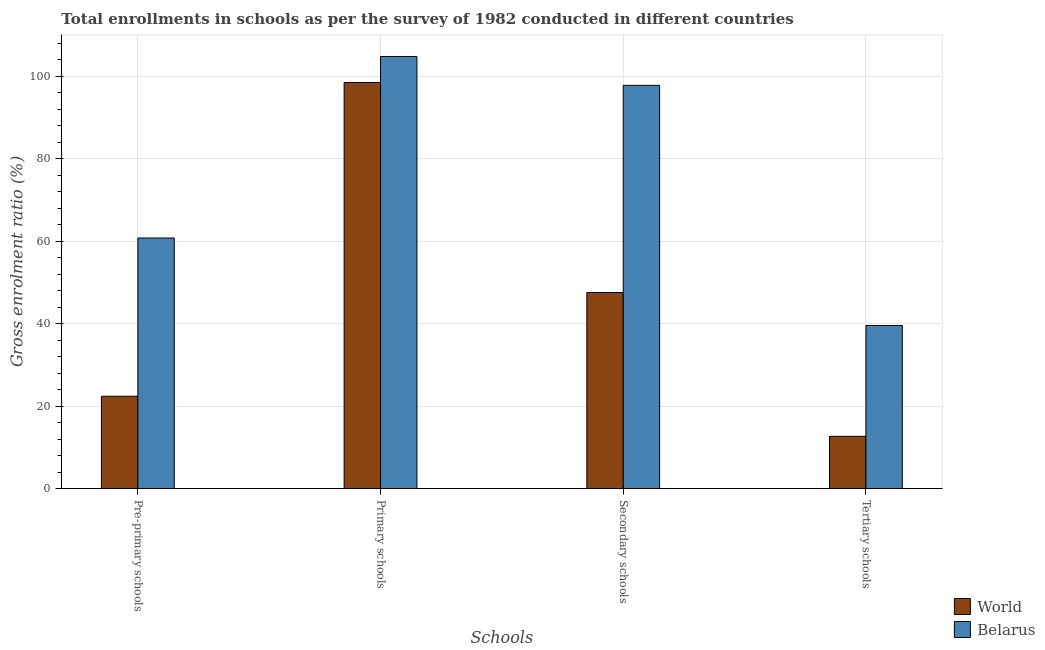How many different coloured bars are there?
Your answer should be very brief. 2. Are the number of bars per tick equal to the number of legend labels?
Your response must be concise. Yes. Are the number of bars on each tick of the X-axis equal?
Offer a very short reply. Yes. How many bars are there on the 4th tick from the left?
Offer a very short reply. 2. How many bars are there on the 1st tick from the right?
Offer a terse response. 2. What is the label of the 2nd group of bars from the left?
Make the answer very short. Primary schools. What is the gross enrolment ratio in pre-primary schools in World?
Your answer should be very brief. 22.41. Across all countries, what is the maximum gross enrolment ratio in pre-primary schools?
Provide a succinct answer. 60.76. Across all countries, what is the minimum gross enrolment ratio in pre-primary schools?
Your answer should be very brief. 22.41. In which country was the gross enrolment ratio in primary schools maximum?
Your answer should be very brief. Belarus. In which country was the gross enrolment ratio in pre-primary schools minimum?
Give a very brief answer. World. What is the total gross enrolment ratio in tertiary schools in the graph?
Provide a short and direct response. 52.24. What is the difference between the gross enrolment ratio in primary schools in Belarus and that in World?
Provide a succinct answer. 6.3. What is the difference between the gross enrolment ratio in tertiary schools in World and the gross enrolment ratio in pre-primary schools in Belarus?
Your response must be concise. -48.07. What is the average gross enrolment ratio in primary schools per country?
Make the answer very short. 101.61. What is the difference between the gross enrolment ratio in secondary schools and gross enrolment ratio in primary schools in World?
Your response must be concise. -50.91. In how many countries, is the gross enrolment ratio in primary schools greater than 68 %?
Give a very brief answer. 2. What is the ratio of the gross enrolment ratio in pre-primary schools in World to that in Belarus?
Make the answer very short. 0.37. What is the difference between the highest and the second highest gross enrolment ratio in tertiary schools?
Keep it short and to the point. 26.87. What is the difference between the highest and the lowest gross enrolment ratio in pre-primary schools?
Provide a short and direct response. 38.35. In how many countries, is the gross enrolment ratio in pre-primary schools greater than the average gross enrolment ratio in pre-primary schools taken over all countries?
Your answer should be compact. 1. What does the 2nd bar from the left in Secondary schools represents?
Keep it short and to the point. Belarus. What does the 1st bar from the right in Primary schools represents?
Ensure brevity in your answer.  Belarus. How many countries are there in the graph?
Offer a very short reply. 2. What is the difference between two consecutive major ticks on the Y-axis?
Your answer should be compact. 20. Are the values on the major ticks of Y-axis written in scientific E-notation?
Keep it short and to the point. No. Does the graph contain grids?
Give a very brief answer. Yes. What is the title of the graph?
Give a very brief answer. Total enrollments in schools as per the survey of 1982 conducted in different countries. What is the label or title of the X-axis?
Offer a terse response. Schools. What is the label or title of the Y-axis?
Give a very brief answer. Gross enrolment ratio (%). What is the Gross enrolment ratio (%) in World in Pre-primary schools?
Provide a succinct answer. 22.41. What is the Gross enrolment ratio (%) in Belarus in Pre-primary schools?
Ensure brevity in your answer.  60.76. What is the Gross enrolment ratio (%) of World in Primary schools?
Your response must be concise. 98.46. What is the Gross enrolment ratio (%) of Belarus in Primary schools?
Provide a succinct answer. 104.76. What is the Gross enrolment ratio (%) in World in Secondary schools?
Offer a terse response. 47.55. What is the Gross enrolment ratio (%) in Belarus in Secondary schools?
Ensure brevity in your answer.  97.76. What is the Gross enrolment ratio (%) in World in Tertiary schools?
Provide a short and direct response. 12.69. What is the Gross enrolment ratio (%) of Belarus in Tertiary schools?
Keep it short and to the point. 39.55. Across all Schools, what is the maximum Gross enrolment ratio (%) in World?
Your response must be concise. 98.46. Across all Schools, what is the maximum Gross enrolment ratio (%) in Belarus?
Provide a short and direct response. 104.76. Across all Schools, what is the minimum Gross enrolment ratio (%) of World?
Offer a very short reply. 12.69. Across all Schools, what is the minimum Gross enrolment ratio (%) of Belarus?
Your response must be concise. 39.55. What is the total Gross enrolment ratio (%) of World in the graph?
Provide a succinct answer. 181.1. What is the total Gross enrolment ratio (%) of Belarus in the graph?
Offer a terse response. 302.84. What is the difference between the Gross enrolment ratio (%) in World in Pre-primary schools and that in Primary schools?
Offer a terse response. -76.05. What is the difference between the Gross enrolment ratio (%) of Belarus in Pre-primary schools and that in Primary schools?
Keep it short and to the point. -44. What is the difference between the Gross enrolment ratio (%) in World in Pre-primary schools and that in Secondary schools?
Your answer should be compact. -25.14. What is the difference between the Gross enrolment ratio (%) of Belarus in Pre-primary schools and that in Secondary schools?
Your response must be concise. -37. What is the difference between the Gross enrolment ratio (%) in World in Pre-primary schools and that in Tertiary schools?
Offer a very short reply. 9.72. What is the difference between the Gross enrolment ratio (%) of Belarus in Pre-primary schools and that in Tertiary schools?
Give a very brief answer. 21.21. What is the difference between the Gross enrolment ratio (%) in World in Primary schools and that in Secondary schools?
Keep it short and to the point. 50.91. What is the difference between the Gross enrolment ratio (%) in Belarus in Primary schools and that in Secondary schools?
Your answer should be very brief. 7. What is the difference between the Gross enrolment ratio (%) of World in Primary schools and that in Tertiary schools?
Provide a short and direct response. 85.77. What is the difference between the Gross enrolment ratio (%) of Belarus in Primary schools and that in Tertiary schools?
Your answer should be compact. 65.2. What is the difference between the Gross enrolment ratio (%) in World in Secondary schools and that in Tertiary schools?
Give a very brief answer. 34.86. What is the difference between the Gross enrolment ratio (%) of Belarus in Secondary schools and that in Tertiary schools?
Your answer should be compact. 58.21. What is the difference between the Gross enrolment ratio (%) of World in Pre-primary schools and the Gross enrolment ratio (%) of Belarus in Primary schools?
Keep it short and to the point. -82.35. What is the difference between the Gross enrolment ratio (%) of World in Pre-primary schools and the Gross enrolment ratio (%) of Belarus in Secondary schools?
Your response must be concise. -75.35. What is the difference between the Gross enrolment ratio (%) in World in Pre-primary schools and the Gross enrolment ratio (%) in Belarus in Tertiary schools?
Offer a very short reply. -17.15. What is the difference between the Gross enrolment ratio (%) in World in Primary schools and the Gross enrolment ratio (%) in Belarus in Secondary schools?
Your answer should be very brief. 0.69. What is the difference between the Gross enrolment ratio (%) in World in Primary schools and the Gross enrolment ratio (%) in Belarus in Tertiary schools?
Ensure brevity in your answer.  58.9. What is the difference between the Gross enrolment ratio (%) of World in Secondary schools and the Gross enrolment ratio (%) of Belarus in Tertiary schools?
Your answer should be compact. 7.99. What is the average Gross enrolment ratio (%) in World per Schools?
Offer a very short reply. 45.27. What is the average Gross enrolment ratio (%) in Belarus per Schools?
Offer a very short reply. 75.71. What is the difference between the Gross enrolment ratio (%) in World and Gross enrolment ratio (%) in Belarus in Pre-primary schools?
Keep it short and to the point. -38.35. What is the difference between the Gross enrolment ratio (%) of World and Gross enrolment ratio (%) of Belarus in Primary schools?
Your answer should be compact. -6.3. What is the difference between the Gross enrolment ratio (%) of World and Gross enrolment ratio (%) of Belarus in Secondary schools?
Ensure brevity in your answer.  -50.22. What is the difference between the Gross enrolment ratio (%) in World and Gross enrolment ratio (%) in Belarus in Tertiary schools?
Your response must be concise. -26.87. What is the ratio of the Gross enrolment ratio (%) in World in Pre-primary schools to that in Primary schools?
Offer a terse response. 0.23. What is the ratio of the Gross enrolment ratio (%) of Belarus in Pre-primary schools to that in Primary schools?
Your response must be concise. 0.58. What is the ratio of the Gross enrolment ratio (%) in World in Pre-primary schools to that in Secondary schools?
Provide a succinct answer. 0.47. What is the ratio of the Gross enrolment ratio (%) in Belarus in Pre-primary schools to that in Secondary schools?
Provide a succinct answer. 0.62. What is the ratio of the Gross enrolment ratio (%) in World in Pre-primary schools to that in Tertiary schools?
Offer a very short reply. 1.77. What is the ratio of the Gross enrolment ratio (%) in Belarus in Pre-primary schools to that in Tertiary schools?
Keep it short and to the point. 1.54. What is the ratio of the Gross enrolment ratio (%) in World in Primary schools to that in Secondary schools?
Your answer should be very brief. 2.07. What is the ratio of the Gross enrolment ratio (%) of Belarus in Primary schools to that in Secondary schools?
Offer a very short reply. 1.07. What is the ratio of the Gross enrolment ratio (%) of World in Primary schools to that in Tertiary schools?
Provide a succinct answer. 7.76. What is the ratio of the Gross enrolment ratio (%) of Belarus in Primary schools to that in Tertiary schools?
Offer a very short reply. 2.65. What is the ratio of the Gross enrolment ratio (%) of World in Secondary schools to that in Tertiary schools?
Offer a very short reply. 3.75. What is the ratio of the Gross enrolment ratio (%) in Belarus in Secondary schools to that in Tertiary schools?
Give a very brief answer. 2.47. What is the difference between the highest and the second highest Gross enrolment ratio (%) of World?
Your response must be concise. 50.91. What is the difference between the highest and the second highest Gross enrolment ratio (%) of Belarus?
Make the answer very short. 7. What is the difference between the highest and the lowest Gross enrolment ratio (%) of World?
Give a very brief answer. 85.77. What is the difference between the highest and the lowest Gross enrolment ratio (%) in Belarus?
Offer a very short reply. 65.2. 